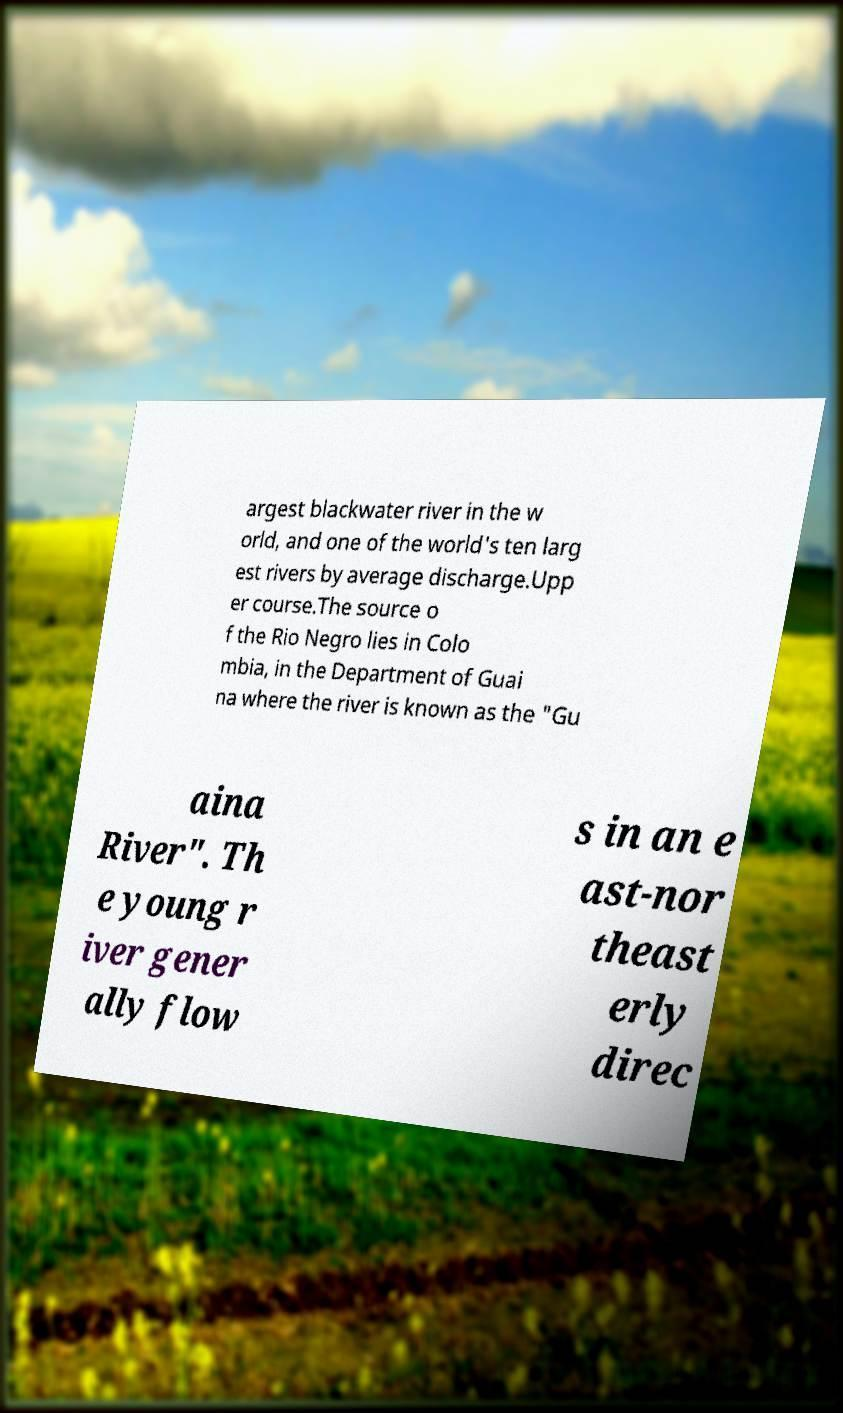Can you accurately transcribe the text from the provided image for me? argest blackwater river in the w orld, and one of the world's ten larg est rivers by average discharge.Upp er course.The source o f the Rio Negro lies in Colo mbia, in the Department of Guai na where the river is known as the "Gu aina River". Th e young r iver gener ally flow s in an e ast-nor theast erly direc 